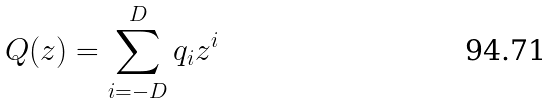<formula> <loc_0><loc_0><loc_500><loc_500>Q ( z ) = \sum _ { i = - D } ^ { D } q _ { i } z ^ { i }</formula> 